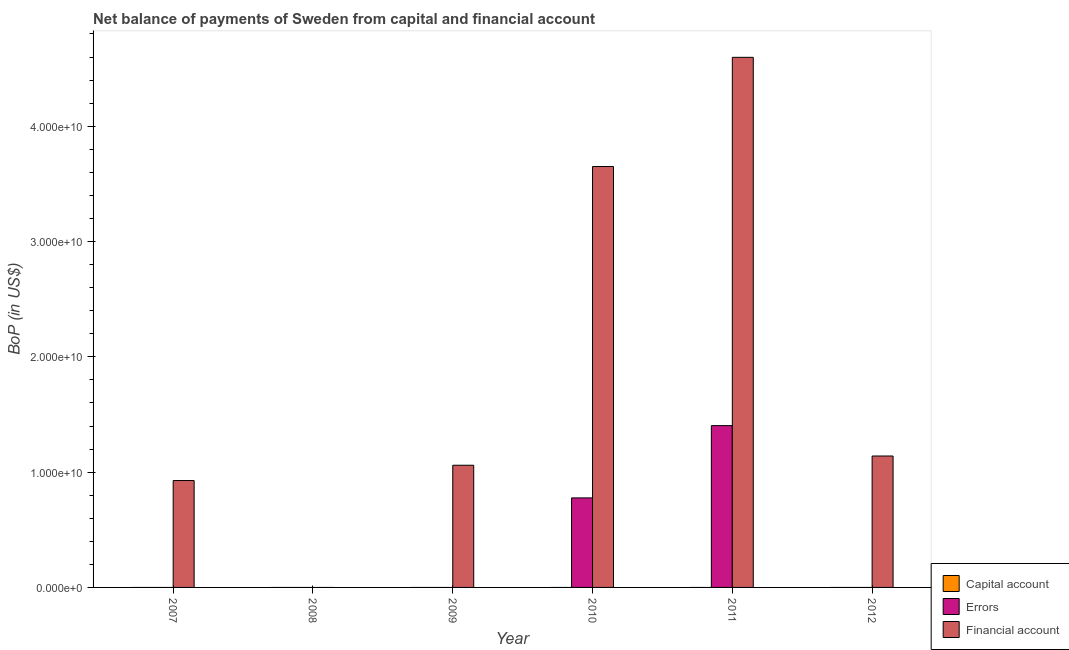Are the number of bars per tick equal to the number of legend labels?
Offer a very short reply. No. How many bars are there on the 6th tick from the right?
Provide a succinct answer. 1. What is the amount of errors in 2009?
Your response must be concise. 0. Across all years, what is the maximum amount of errors?
Offer a terse response. 1.40e+1. Across all years, what is the minimum amount of net capital account?
Ensure brevity in your answer.  0. In which year was the amount of errors maximum?
Make the answer very short. 2011. What is the difference between the amount of financial account in 2010 and that in 2012?
Provide a short and direct response. 2.51e+1. What is the average amount of financial account per year?
Keep it short and to the point. 1.90e+1. In how many years, is the amount of financial account greater than 30000000000 US$?
Your answer should be compact. 2. What is the ratio of the amount of financial account in 2009 to that in 2011?
Your response must be concise. 0.23. Is the difference between the amount of financial account in 2007 and 2012 greater than the difference between the amount of errors in 2007 and 2012?
Your answer should be compact. No. What is the difference between the highest and the second highest amount of financial account?
Provide a short and direct response. 9.47e+09. What is the difference between the highest and the lowest amount of financial account?
Provide a succinct answer. 4.60e+1. In how many years, is the amount of net capital account greater than the average amount of net capital account taken over all years?
Offer a very short reply. 0. Are all the bars in the graph horizontal?
Your answer should be very brief. No. How many years are there in the graph?
Offer a terse response. 6. Does the graph contain grids?
Keep it short and to the point. No. Where does the legend appear in the graph?
Offer a very short reply. Bottom right. How many legend labels are there?
Give a very brief answer. 3. What is the title of the graph?
Offer a very short reply. Net balance of payments of Sweden from capital and financial account. What is the label or title of the X-axis?
Make the answer very short. Year. What is the label or title of the Y-axis?
Your answer should be very brief. BoP (in US$). What is the BoP (in US$) of Capital account in 2007?
Your answer should be compact. 0. What is the BoP (in US$) of Errors in 2007?
Offer a terse response. 0. What is the BoP (in US$) of Financial account in 2007?
Keep it short and to the point. 9.27e+09. What is the BoP (in US$) of Capital account in 2008?
Provide a short and direct response. 0. What is the BoP (in US$) of Errors in 2008?
Provide a short and direct response. 0. What is the BoP (in US$) of Capital account in 2009?
Your response must be concise. 0. What is the BoP (in US$) in Errors in 2009?
Provide a short and direct response. 0. What is the BoP (in US$) of Financial account in 2009?
Give a very brief answer. 1.06e+1. What is the BoP (in US$) of Errors in 2010?
Offer a terse response. 7.76e+09. What is the BoP (in US$) in Financial account in 2010?
Your answer should be very brief. 3.65e+1. What is the BoP (in US$) in Capital account in 2011?
Ensure brevity in your answer.  0. What is the BoP (in US$) in Errors in 2011?
Your response must be concise. 1.40e+1. What is the BoP (in US$) in Financial account in 2011?
Provide a succinct answer. 4.60e+1. What is the BoP (in US$) of Capital account in 2012?
Provide a short and direct response. 0. What is the BoP (in US$) in Financial account in 2012?
Your answer should be very brief. 1.14e+1. Across all years, what is the maximum BoP (in US$) in Errors?
Your answer should be very brief. 1.40e+1. Across all years, what is the maximum BoP (in US$) of Financial account?
Provide a succinct answer. 4.60e+1. Across all years, what is the minimum BoP (in US$) of Errors?
Your answer should be compact. 0. Across all years, what is the minimum BoP (in US$) of Financial account?
Your response must be concise. 0. What is the total BoP (in US$) in Capital account in the graph?
Make the answer very short. 0. What is the total BoP (in US$) of Errors in the graph?
Make the answer very short. 2.18e+1. What is the total BoP (in US$) in Financial account in the graph?
Provide a short and direct response. 1.14e+11. What is the difference between the BoP (in US$) in Financial account in 2007 and that in 2009?
Make the answer very short. -1.33e+09. What is the difference between the BoP (in US$) of Financial account in 2007 and that in 2010?
Your response must be concise. -2.72e+1. What is the difference between the BoP (in US$) in Financial account in 2007 and that in 2011?
Keep it short and to the point. -3.67e+1. What is the difference between the BoP (in US$) of Financial account in 2007 and that in 2012?
Ensure brevity in your answer.  -2.13e+09. What is the difference between the BoP (in US$) of Financial account in 2009 and that in 2010?
Provide a short and direct response. -2.59e+1. What is the difference between the BoP (in US$) in Financial account in 2009 and that in 2011?
Ensure brevity in your answer.  -3.54e+1. What is the difference between the BoP (in US$) of Financial account in 2009 and that in 2012?
Ensure brevity in your answer.  -8.00e+08. What is the difference between the BoP (in US$) of Errors in 2010 and that in 2011?
Offer a very short reply. -6.27e+09. What is the difference between the BoP (in US$) of Financial account in 2010 and that in 2011?
Keep it short and to the point. -9.47e+09. What is the difference between the BoP (in US$) of Financial account in 2010 and that in 2012?
Your answer should be compact. 2.51e+1. What is the difference between the BoP (in US$) of Financial account in 2011 and that in 2012?
Give a very brief answer. 3.46e+1. What is the difference between the BoP (in US$) of Errors in 2010 and the BoP (in US$) of Financial account in 2011?
Provide a short and direct response. -3.82e+1. What is the difference between the BoP (in US$) in Errors in 2010 and the BoP (in US$) in Financial account in 2012?
Your answer should be compact. -3.63e+09. What is the difference between the BoP (in US$) of Errors in 2011 and the BoP (in US$) of Financial account in 2012?
Your answer should be compact. 2.64e+09. What is the average BoP (in US$) in Capital account per year?
Make the answer very short. 0. What is the average BoP (in US$) of Errors per year?
Make the answer very short. 3.63e+09. What is the average BoP (in US$) of Financial account per year?
Provide a succinct answer. 1.90e+1. In the year 2010, what is the difference between the BoP (in US$) of Errors and BoP (in US$) of Financial account?
Your answer should be very brief. -2.87e+1. In the year 2011, what is the difference between the BoP (in US$) in Errors and BoP (in US$) in Financial account?
Give a very brief answer. -3.19e+1. What is the ratio of the BoP (in US$) in Financial account in 2007 to that in 2009?
Ensure brevity in your answer.  0.87. What is the ratio of the BoP (in US$) of Financial account in 2007 to that in 2010?
Provide a short and direct response. 0.25. What is the ratio of the BoP (in US$) of Financial account in 2007 to that in 2011?
Provide a short and direct response. 0.2. What is the ratio of the BoP (in US$) in Financial account in 2007 to that in 2012?
Ensure brevity in your answer.  0.81. What is the ratio of the BoP (in US$) of Financial account in 2009 to that in 2010?
Your response must be concise. 0.29. What is the ratio of the BoP (in US$) of Financial account in 2009 to that in 2011?
Your answer should be compact. 0.23. What is the ratio of the BoP (in US$) in Financial account in 2009 to that in 2012?
Provide a short and direct response. 0.93. What is the ratio of the BoP (in US$) of Errors in 2010 to that in 2011?
Your answer should be compact. 0.55. What is the ratio of the BoP (in US$) in Financial account in 2010 to that in 2011?
Provide a succinct answer. 0.79. What is the ratio of the BoP (in US$) of Financial account in 2010 to that in 2012?
Your answer should be very brief. 3.2. What is the ratio of the BoP (in US$) of Financial account in 2011 to that in 2012?
Offer a terse response. 4.03. What is the difference between the highest and the second highest BoP (in US$) in Financial account?
Offer a very short reply. 9.47e+09. What is the difference between the highest and the lowest BoP (in US$) of Errors?
Provide a short and direct response. 1.40e+1. What is the difference between the highest and the lowest BoP (in US$) of Financial account?
Offer a very short reply. 4.60e+1. 